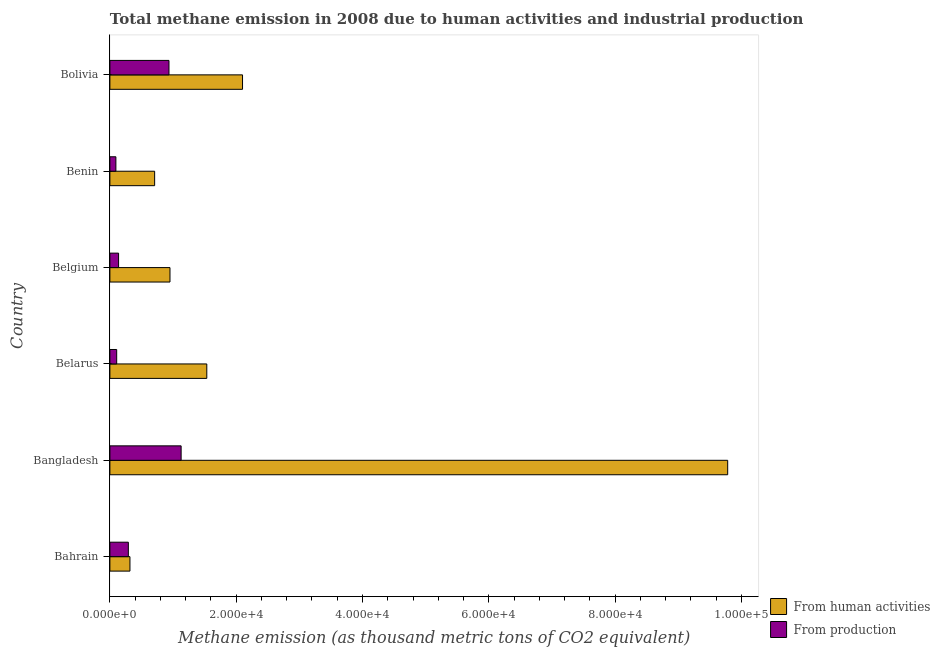How many groups of bars are there?
Keep it short and to the point. 6. Are the number of bars per tick equal to the number of legend labels?
Your answer should be very brief. Yes. Are the number of bars on each tick of the Y-axis equal?
Your response must be concise. Yes. How many bars are there on the 6th tick from the top?
Make the answer very short. 2. What is the label of the 6th group of bars from the top?
Provide a succinct answer. Bahrain. In how many cases, is the number of bars for a given country not equal to the number of legend labels?
Offer a terse response. 0. What is the amount of emissions generated from industries in Bahrain?
Your answer should be very brief. 2923.2. Across all countries, what is the maximum amount of emissions generated from industries?
Provide a succinct answer. 1.13e+04. Across all countries, what is the minimum amount of emissions generated from industries?
Your response must be concise. 950.4. In which country was the amount of emissions generated from industries minimum?
Provide a succinct answer. Benin. What is the total amount of emissions from human activities in the graph?
Ensure brevity in your answer.  1.54e+05. What is the difference between the amount of emissions generated from industries in Belarus and that in Bolivia?
Your response must be concise. -8279.1. What is the difference between the amount of emissions from human activities in Benin and the amount of emissions generated from industries in Bahrain?
Provide a short and direct response. 4163.4. What is the average amount of emissions generated from industries per country?
Your response must be concise. 4493.78. What is the difference between the amount of emissions from human activities and amount of emissions generated from industries in Bahrain?
Your answer should be compact. 253.2. In how many countries, is the amount of emissions generated from industries greater than 16000 thousand metric tons?
Offer a very short reply. 0. What is the ratio of the amount of emissions from human activities in Bahrain to that in Belgium?
Provide a short and direct response. 0.33. What is the difference between the highest and the second highest amount of emissions from human activities?
Your response must be concise. 7.68e+04. What is the difference between the highest and the lowest amount of emissions from human activities?
Your answer should be compact. 9.47e+04. In how many countries, is the amount of emissions generated from industries greater than the average amount of emissions generated from industries taken over all countries?
Provide a succinct answer. 2. What does the 1st bar from the top in Bangladesh represents?
Your answer should be compact. From production. What does the 1st bar from the bottom in Bolivia represents?
Ensure brevity in your answer.  From human activities. How many bars are there?
Provide a succinct answer. 12. How many countries are there in the graph?
Your answer should be very brief. 6. What is the difference between two consecutive major ticks on the X-axis?
Make the answer very short. 2.00e+04. Does the graph contain grids?
Provide a short and direct response. No. How many legend labels are there?
Your answer should be compact. 2. What is the title of the graph?
Provide a short and direct response. Total methane emission in 2008 due to human activities and industrial production. Does "Central government" appear as one of the legend labels in the graph?
Offer a very short reply. No. What is the label or title of the X-axis?
Your answer should be compact. Methane emission (as thousand metric tons of CO2 equivalent). What is the Methane emission (as thousand metric tons of CO2 equivalent) in From human activities in Bahrain?
Keep it short and to the point. 3176.4. What is the Methane emission (as thousand metric tons of CO2 equivalent) of From production in Bahrain?
Ensure brevity in your answer.  2923.2. What is the Methane emission (as thousand metric tons of CO2 equivalent) in From human activities in Bangladesh?
Provide a short and direct response. 9.78e+04. What is the Methane emission (as thousand metric tons of CO2 equivalent) in From production in Bangladesh?
Offer a terse response. 1.13e+04. What is the Methane emission (as thousand metric tons of CO2 equivalent) of From human activities in Belarus?
Your response must be concise. 1.53e+04. What is the Methane emission (as thousand metric tons of CO2 equivalent) in From production in Belarus?
Ensure brevity in your answer.  1077.2. What is the Methane emission (as thousand metric tons of CO2 equivalent) of From human activities in Belgium?
Make the answer very short. 9515.5. What is the Methane emission (as thousand metric tons of CO2 equivalent) in From production in Belgium?
Your answer should be compact. 1376.4. What is the Methane emission (as thousand metric tons of CO2 equivalent) in From human activities in Benin?
Provide a short and direct response. 7086.6. What is the Methane emission (as thousand metric tons of CO2 equivalent) in From production in Benin?
Your response must be concise. 950.4. What is the Methane emission (as thousand metric tons of CO2 equivalent) in From human activities in Bolivia?
Your response must be concise. 2.10e+04. What is the Methane emission (as thousand metric tons of CO2 equivalent) in From production in Bolivia?
Give a very brief answer. 9356.3. Across all countries, what is the maximum Methane emission (as thousand metric tons of CO2 equivalent) of From human activities?
Provide a short and direct response. 9.78e+04. Across all countries, what is the maximum Methane emission (as thousand metric tons of CO2 equivalent) of From production?
Give a very brief answer. 1.13e+04. Across all countries, what is the minimum Methane emission (as thousand metric tons of CO2 equivalent) of From human activities?
Your answer should be very brief. 3176.4. Across all countries, what is the minimum Methane emission (as thousand metric tons of CO2 equivalent) of From production?
Your answer should be very brief. 950.4. What is the total Methane emission (as thousand metric tons of CO2 equivalent) of From human activities in the graph?
Keep it short and to the point. 1.54e+05. What is the total Methane emission (as thousand metric tons of CO2 equivalent) of From production in the graph?
Ensure brevity in your answer.  2.70e+04. What is the difference between the Methane emission (as thousand metric tons of CO2 equivalent) of From human activities in Bahrain and that in Bangladesh?
Provide a short and direct response. -9.47e+04. What is the difference between the Methane emission (as thousand metric tons of CO2 equivalent) in From production in Bahrain and that in Bangladesh?
Provide a short and direct response. -8356. What is the difference between the Methane emission (as thousand metric tons of CO2 equivalent) of From human activities in Bahrain and that in Belarus?
Provide a succinct answer. -1.22e+04. What is the difference between the Methane emission (as thousand metric tons of CO2 equivalent) of From production in Bahrain and that in Belarus?
Give a very brief answer. 1846. What is the difference between the Methane emission (as thousand metric tons of CO2 equivalent) of From human activities in Bahrain and that in Belgium?
Your answer should be compact. -6339.1. What is the difference between the Methane emission (as thousand metric tons of CO2 equivalent) in From production in Bahrain and that in Belgium?
Offer a terse response. 1546.8. What is the difference between the Methane emission (as thousand metric tons of CO2 equivalent) in From human activities in Bahrain and that in Benin?
Provide a short and direct response. -3910.2. What is the difference between the Methane emission (as thousand metric tons of CO2 equivalent) of From production in Bahrain and that in Benin?
Your answer should be compact. 1972.8. What is the difference between the Methane emission (as thousand metric tons of CO2 equivalent) in From human activities in Bahrain and that in Bolivia?
Provide a short and direct response. -1.78e+04. What is the difference between the Methane emission (as thousand metric tons of CO2 equivalent) of From production in Bahrain and that in Bolivia?
Give a very brief answer. -6433.1. What is the difference between the Methane emission (as thousand metric tons of CO2 equivalent) in From human activities in Bangladesh and that in Belarus?
Your response must be concise. 8.25e+04. What is the difference between the Methane emission (as thousand metric tons of CO2 equivalent) in From production in Bangladesh and that in Belarus?
Your answer should be compact. 1.02e+04. What is the difference between the Methane emission (as thousand metric tons of CO2 equivalent) in From human activities in Bangladesh and that in Belgium?
Your answer should be compact. 8.83e+04. What is the difference between the Methane emission (as thousand metric tons of CO2 equivalent) in From production in Bangladesh and that in Belgium?
Offer a terse response. 9902.8. What is the difference between the Methane emission (as thousand metric tons of CO2 equivalent) in From human activities in Bangladesh and that in Benin?
Your response must be concise. 9.07e+04. What is the difference between the Methane emission (as thousand metric tons of CO2 equivalent) in From production in Bangladesh and that in Benin?
Give a very brief answer. 1.03e+04. What is the difference between the Methane emission (as thousand metric tons of CO2 equivalent) of From human activities in Bangladesh and that in Bolivia?
Provide a short and direct response. 7.68e+04. What is the difference between the Methane emission (as thousand metric tons of CO2 equivalent) of From production in Bangladesh and that in Bolivia?
Make the answer very short. 1922.9. What is the difference between the Methane emission (as thousand metric tons of CO2 equivalent) of From human activities in Belarus and that in Belgium?
Provide a short and direct response. 5828.7. What is the difference between the Methane emission (as thousand metric tons of CO2 equivalent) of From production in Belarus and that in Belgium?
Your answer should be compact. -299.2. What is the difference between the Methane emission (as thousand metric tons of CO2 equivalent) in From human activities in Belarus and that in Benin?
Your answer should be compact. 8257.6. What is the difference between the Methane emission (as thousand metric tons of CO2 equivalent) of From production in Belarus and that in Benin?
Ensure brevity in your answer.  126.8. What is the difference between the Methane emission (as thousand metric tons of CO2 equivalent) in From human activities in Belarus and that in Bolivia?
Provide a succinct answer. -5658.8. What is the difference between the Methane emission (as thousand metric tons of CO2 equivalent) in From production in Belarus and that in Bolivia?
Provide a succinct answer. -8279.1. What is the difference between the Methane emission (as thousand metric tons of CO2 equivalent) in From human activities in Belgium and that in Benin?
Provide a short and direct response. 2428.9. What is the difference between the Methane emission (as thousand metric tons of CO2 equivalent) of From production in Belgium and that in Benin?
Ensure brevity in your answer.  426. What is the difference between the Methane emission (as thousand metric tons of CO2 equivalent) of From human activities in Belgium and that in Bolivia?
Offer a very short reply. -1.15e+04. What is the difference between the Methane emission (as thousand metric tons of CO2 equivalent) of From production in Belgium and that in Bolivia?
Offer a terse response. -7979.9. What is the difference between the Methane emission (as thousand metric tons of CO2 equivalent) in From human activities in Benin and that in Bolivia?
Your answer should be compact. -1.39e+04. What is the difference between the Methane emission (as thousand metric tons of CO2 equivalent) of From production in Benin and that in Bolivia?
Provide a short and direct response. -8405.9. What is the difference between the Methane emission (as thousand metric tons of CO2 equivalent) of From human activities in Bahrain and the Methane emission (as thousand metric tons of CO2 equivalent) of From production in Bangladesh?
Provide a succinct answer. -8102.8. What is the difference between the Methane emission (as thousand metric tons of CO2 equivalent) of From human activities in Bahrain and the Methane emission (as thousand metric tons of CO2 equivalent) of From production in Belarus?
Offer a terse response. 2099.2. What is the difference between the Methane emission (as thousand metric tons of CO2 equivalent) of From human activities in Bahrain and the Methane emission (as thousand metric tons of CO2 equivalent) of From production in Belgium?
Give a very brief answer. 1800. What is the difference between the Methane emission (as thousand metric tons of CO2 equivalent) in From human activities in Bahrain and the Methane emission (as thousand metric tons of CO2 equivalent) in From production in Benin?
Your answer should be very brief. 2226. What is the difference between the Methane emission (as thousand metric tons of CO2 equivalent) of From human activities in Bahrain and the Methane emission (as thousand metric tons of CO2 equivalent) of From production in Bolivia?
Your answer should be compact. -6179.9. What is the difference between the Methane emission (as thousand metric tons of CO2 equivalent) in From human activities in Bangladesh and the Methane emission (as thousand metric tons of CO2 equivalent) in From production in Belarus?
Provide a short and direct response. 9.68e+04. What is the difference between the Methane emission (as thousand metric tons of CO2 equivalent) in From human activities in Bangladesh and the Methane emission (as thousand metric tons of CO2 equivalent) in From production in Belgium?
Ensure brevity in your answer.  9.65e+04. What is the difference between the Methane emission (as thousand metric tons of CO2 equivalent) in From human activities in Bangladesh and the Methane emission (as thousand metric tons of CO2 equivalent) in From production in Benin?
Your answer should be compact. 9.69e+04. What is the difference between the Methane emission (as thousand metric tons of CO2 equivalent) of From human activities in Bangladesh and the Methane emission (as thousand metric tons of CO2 equivalent) of From production in Bolivia?
Make the answer very short. 8.85e+04. What is the difference between the Methane emission (as thousand metric tons of CO2 equivalent) in From human activities in Belarus and the Methane emission (as thousand metric tons of CO2 equivalent) in From production in Belgium?
Make the answer very short. 1.40e+04. What is the difference between the Methane emission (as thousand metric tons of CO2 equivalent) of From human activities in Belarus and the Methane emission (as thousand metric tons of CO2 equivalent) of From production in Benin?
Provide a short and direct response. 1.44e+04. What is the difference between the Methane emission (as thousand metric tons of CO2 equivalent) in From human activities in Belarus and the Methane emission (as thousand metric tons of CO2 equivalent) in From production in Bolivia?
Your answer should be compact. 5987.9. What is the difference between the Methane emission (as thousand metric tons of CO2 equivalent) in From human activities in Belgium and the Methane emission (as thousand metric tons of CO2 equivalent) in From production in Benin?
Keep it short and to the point. 8565.1. What is the difference between the Methane emission (as thousand metric tons of CO2 equivalent) of From human activities in Belgium and the Methane emission (as thousand metric tons of CO2 equivalent) of From production in Bolivia?
Give a very brief answer. 159.2. What is the difference between the Methane emission (as thousand metric tons of CO2 equivalent) of From human activities in Benin and the Methane emission (as thousand metric tons of CO2 equivalent) of From production in Bolivia?
Your answer should be compact. -2269.7. What is the average Methane emission (as thousand metric tons of CO2 equivalent) in From human activities per country?
Your answer should be very brief. 2.57e+04. What is the average Methane emission (as thousand metric tons of CO2 equivalent) of From production per country?
Offer a very short reply. 4493.78. What is the difference between the Methane emission (as thousand metric tons of CO2 equivalent) in From human activities and Methane emission (as thousand metric tons of CO2 equivalent) in From production in Bahrain?
Provide a short and direct response. 253.2. What is the difference between the Methane emission (as thousand metric tons of CO2 equivalent) in From human activities and Methane emission (as thousand metric tons of CO2 equivalent) in From production in Bangladesh?
Provide a short and direct response. 8.65e+04. What is the difference between the Methane emission (as thousand metric tons of CO2 equivalent) of From human activities and Methane emission (as thousand metric tons of CO2 equivalent) of From production in Belarus?
Offer a terse response. 1.43e+04. What is the difference between the Methane emission (as thousand metric tons of CO2 equivalent) of From human activities and Methane emission (as thousand metric tons of CO2 equivalent) of From production in Belgium?
Give a very brief answer. 8139.1. What is the difference between the Methane emission (as thousand metric tons of CO2 equivalent) in From human activities and Methane emission (as thousand metric tons of CO2 equivalent) in From production in Benin?
Your response must be concise. 6136.2. What is the difference between the Methane emission (as thousand metric tons of CO2 equivalent) in From human activities and Methane emission (as thousand metric tons of CO2 equivalent) in From production in Bolivia?
Give a very brief answer. 1.16e+04. What is the ratio of the Methane emission (as thousand metric tons of CO2 equivalent) of From human activities in Bahrain to that in Bangladesh?
Your response must be concise. 0.03. What is the ratio of the Methane emission (as thousand metric tons of CO2 equivalent) in From production in Bahrain to that in Bangladesh?
Ensure brevity in your answer.  0.26. What is the ratio of the Methane emission (as thousand metric tons of CO2 equivalent) of From human activities in Bahrain to that in Belarus?
Offer a terse response. 0.21. What is the ratio of the Methane emission (as thousand metric tons of CO2 equivalent) of From production in Bahrain to that in Belarus?
Offer a terse response. 2.71. What is the ratio of the Methane emission (as thousand metric tons of CO2 equivalent) of From human activities in Bahrain to that in Belgium?
Offer a very short reply. 0.33. What is the ratio of the Methane emission (as thousand metric tons of CO2 equivalent) of From production in Bahrain to that in Belgium?
Keep it short and to the point. 2.12. What is the ratio of the Methane emission (as thousand metric tons of CO2 equivalent) in From human activities in Bahrain to that in Benin?
Your response must be concise. 0.45. What is the ratio of the Methane emission (as thousand metric tons of CO2 equivalent) of From production in Bahrain to that in Benin?
Make the answer very short. 3.08. What is the ratio of the Methane emission (as thousand metric tons of CO2 equivalent) of From human activities in Bahrain to that in Bolivia?
Your answer should be compact. 0.15. What is the ratio of the Methane emission (as thousand metric tons of CO2 equivalent) in From production in Bahrain to that in Bolivia?
Give a very brief answer. 0.31. What is the ratio of the Methane emission (as thousand metric tons of CO2 equivalent) of From human activities in Bangladesh to that in Belarus?
Keep it short and to the point. 6.38. What is the ratio of the Methane emission (as thousand metric tons of CO2 equivalent) in From production in Bangladesh to that in Belarus?
Your answer should be very brief. 10.47. What is the ratio of the Methane emission (as thousand metric tons of CO2 equivalent) of From human activities in Bangladesh to that in Belgium?
Offer a very short reply. 10.28. What is the ratio of the Methane emission (as thousand metric tons of CO2 equivalent) of From production in Bangladesh to that in Belgium?
Your response must be concise. 8.19. What is the ratio of the Methane emission (as thousand metric tons of CO2 equivalent) of From human activities in Bangladesh to that in Benin?
Give a very brief answer. 13.8. What is the ratio of the Methane emission (as thousand metric tons of CO2 equivalent) of From production in Bangladesh to that in Benin?
Offer a very short reply. 11.87. What is the ratio of the Methane emission (as thousand metric tons of CO2 equivalent) in From human activities in Bangladesh to that in Bolivia?
Offer a terse response. 4.66. What is the ratio of the Methane emission (as thousand metric tons of CO2 equivalent) in From production in Bangladesh to that in Bolivia?
Provide a short and direct response. 1.21. What is the ratio of the Methane emission (as thousand metric tons of CO2 equivalent) of From human activities in Belarus to that in Belgium?
Your answer should be very brief. 1.61. What is the ratio of the Methane emission (as thousand metric tons of CO2 equivalent) of From production in Belarus to that in Belgium?
Offer a very short reply. 0.78. What is the ratio of the Methane emission (as thousand metric tons of CO2 equivalent) in From human activities in Belarus to that in Benin?
Provide a succinct answer. 2.17. What is the ratio of the Methane emission (as thousand metric tons of CO2 equivalent) of From production in Belarus to that in Benin?
Keep it short and to the point. 1.13. What is the ratio of the Methane emission (as thousand metric tons of CO2 equivalent) in From human activities in Belarus to that in Bolivia?
Make the answer very short. 0.73. What is the ratio of the Methane emission (as thousand metric tons of CO2 equivalent) of From production in Belarus to that in Bolivia?
Provide a short and direct response. 0.12. What is the ratio of the Methane emission (as thousand metric tons of CO2 equivalent) of From human activities in Belgium to that in Benin?
Offer a very short reply. 1.34. What is the ratio of the Methane emission (as thousand metric tons of CO2 equivalent) of From production in Belgium to that in Benin?
Give a very brief answer. 1.45. What is the ratio of the Methane emission (as thousand metric tons of CO2 equivalent) of From human activities in Belgium to that in Bolivia?
Your answer should be compact. 0.45. What is the ratio of the Methane emission (as thousand metric tons of CO2 equivalent) in From production in Belgium to that in Bolivia?
Offer a terse response. 0.15. What is the ratio of the Methane emission (as thousand metric tons of CO2 equivalent) in From human activities in Benin to that in Bolivia?
Give a very brief answer. 0.34. What is the ratio of the Methane emission (as thousand metric tons of CO2 equivalent) in From production in Benin to that in Bolivia?
Your answer should be compact. 0.1. What is the difference between the highest and the second highest Methane emission (as thousand metric tons of CO2 equivalent) of From human activities?
Keep it short and to the point. 7.68e+04. What is the difference between the highest and the second highest Methane emission (as thousand metric tons of CO2 equivalent) in From production?
Your answer should be very brief. 1922.9. What is the difference between the highest and the lowest Methane emission (as thousand metric tons of CO2 equivalent) in From human activities?
Make the answer very short. 9.47e+04. What is the difference between the highest and the lowest Methane emission (as thousand metric tons of CO2 equivalent) in From production?
Ensure brevity in your answer.  1.03e+04. 